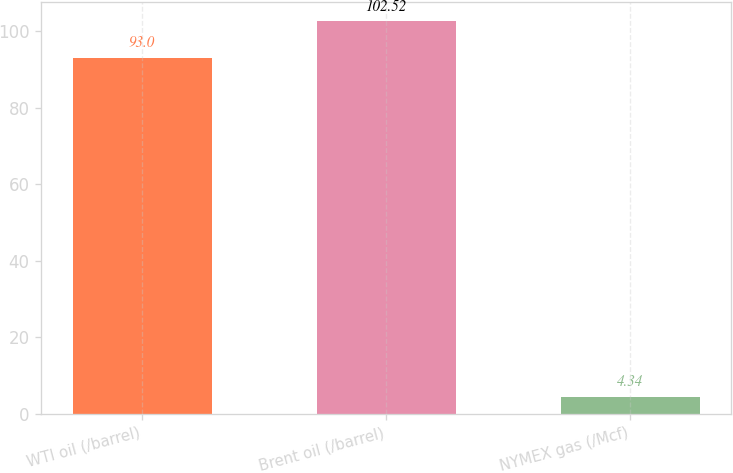<chart> <loc_0><loc_0><loc_500><loc_500><bar_chart><fcel>WTI oil (/barrel)<fcel>Brent oil (/barrel)<fcel>NYMEX gas (/Mcf)<nl><fcel>93<fcel>102.52<fcel>4.34<nl></chart> 